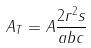<formula> <loc_0><loc_0><loc_500><loc_500>A _ { T } = A \frac { 2 r ^ { 2 } s } { a b c }</formula> 